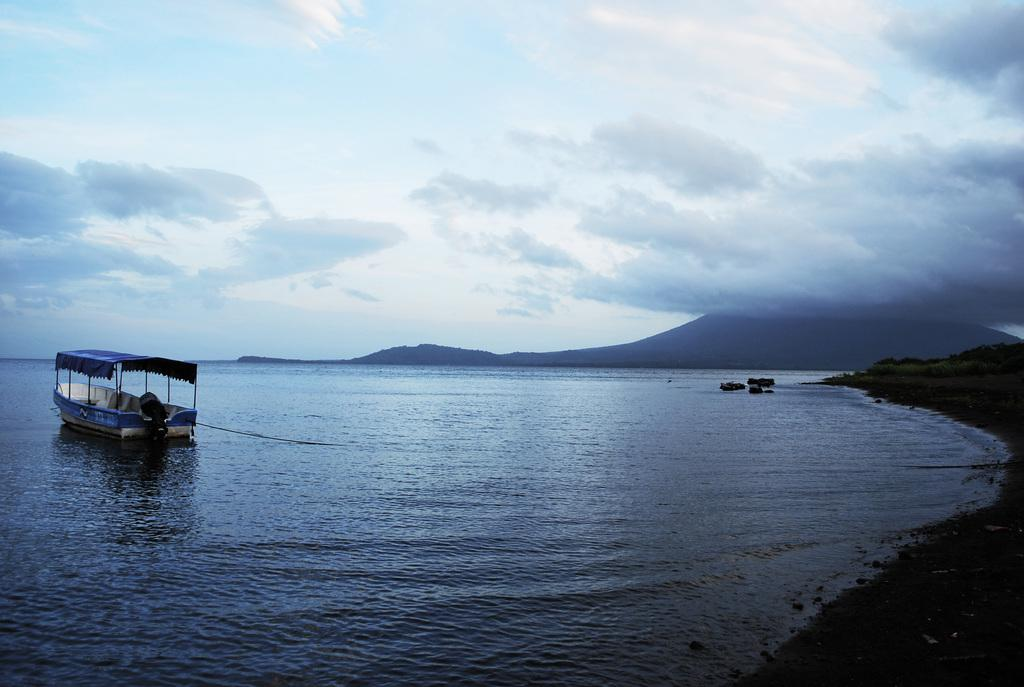What is the main subject of the image? The main subject of the image is water. What is located on the water? There is a boat on the water. What geographical feature can be seen in the background of the image? There is a mountain visible in the image. How would you describe the weather based on the image? The sky is cloudy in the image, suggesting overcast or potentially rainy weather. Can you see any fangs in the image? There are no fangs present in the image. Are there any jellyfish visible in the water? There is no mention of jellyfish in the image, only a boat on the water. 